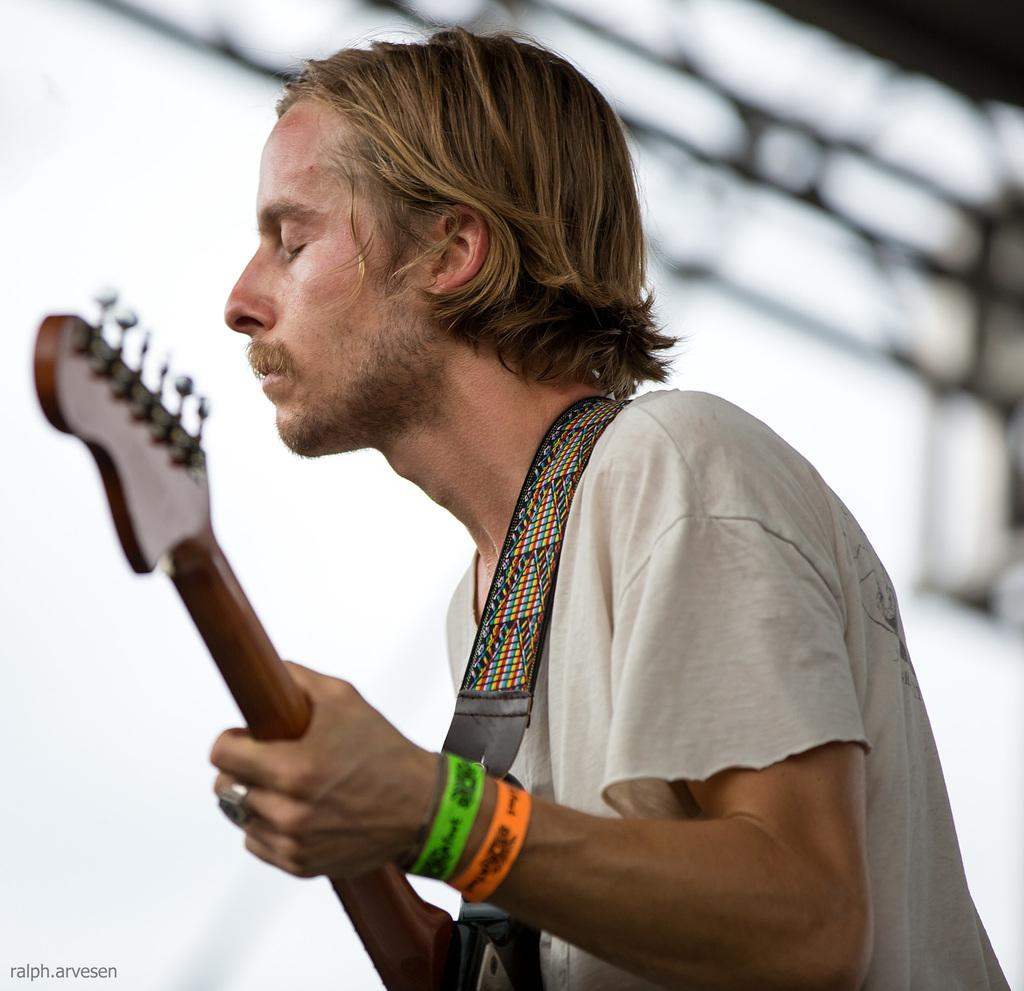What is the main subject of the image? The main subject of the image is a man. What is the man wearing in the image? The man is wearing a white t-shirt in the image. What is the man holding in the image? The man is holding a guitar in the image. What is the man doing in the image? The man is singing a song in the image. What colors are the bands the man is wearing? The man is wearing two bands, one green and one orange. What color is the background behind the man? The background behind the man is blue. How many visitors can be seen in the image? There are no visitors present in the image; it only features a man. What color are the man's eyes in the image? The color of the man's eyes cannot be determined from the image, as it does not show his eyes. 